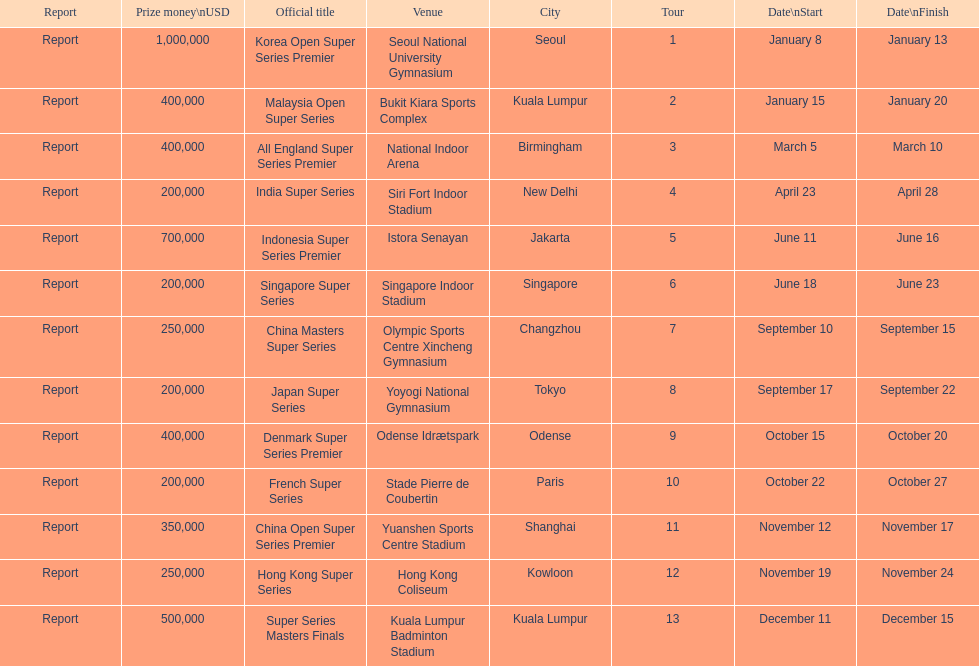How long did the japan super series take? 5 days. 